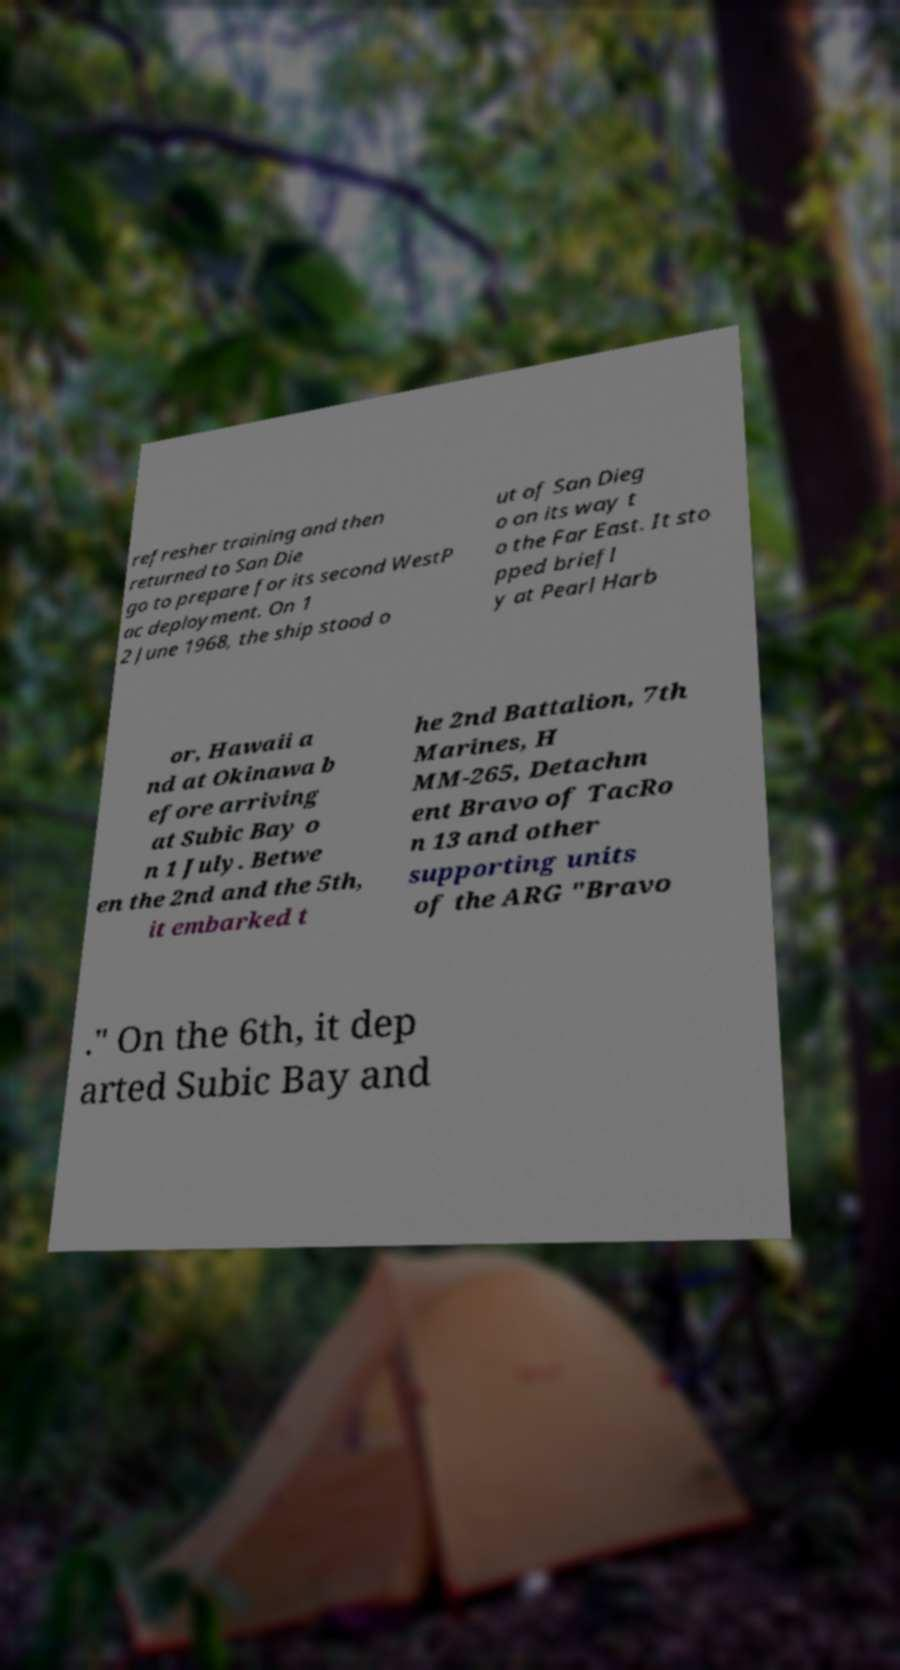For documentation purposes, I need the text within this image transcribed. Could you provide that? refresher training and then returned to San Die go to prepare for its second WestP ac deployment. On 1 2 June 1968, the ship stood o ut of San Dieg o on its way t o the Far East. It sto pped briefl y at Pearl Harb or, Hawaii a nd at Okinawa b efore arriving at Subic Bay o n 1 July. Betwe en the 2nd and the 5th, it embarked t he 2nd Battalion, 7th Marines, H MM-265, Detachm ent Bravo of TacRo n 13 and other supporting units of the ARG "Bravo ." On the 6th, it dep arted Subic Bay and 